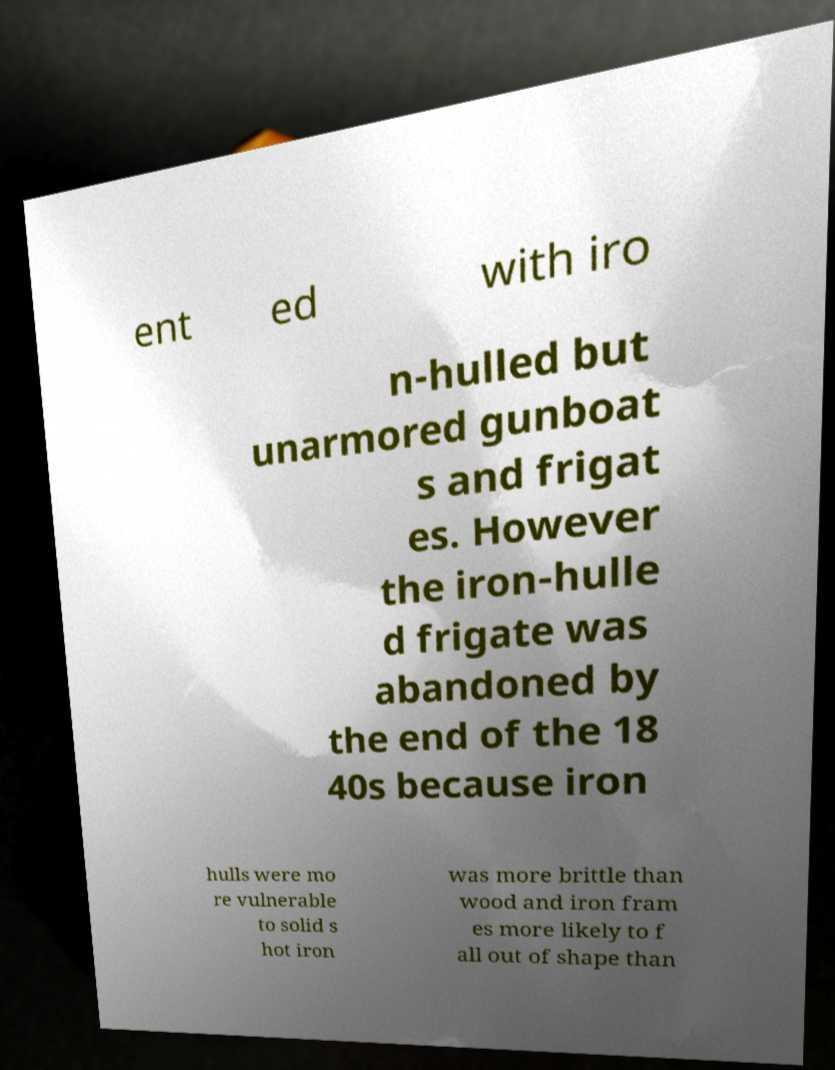I need the written content from this picture converted into text. Can you do that? ent ed with iro n-hulled but unarmored gunboat s and frigat es. However the iron-hulle d frigate was abandoned by the end of the 18 40s because iron hulls were mo re vulnerable to solid s hot iron was more brittle than wood and iron fram es more likely to f all out of shape than 